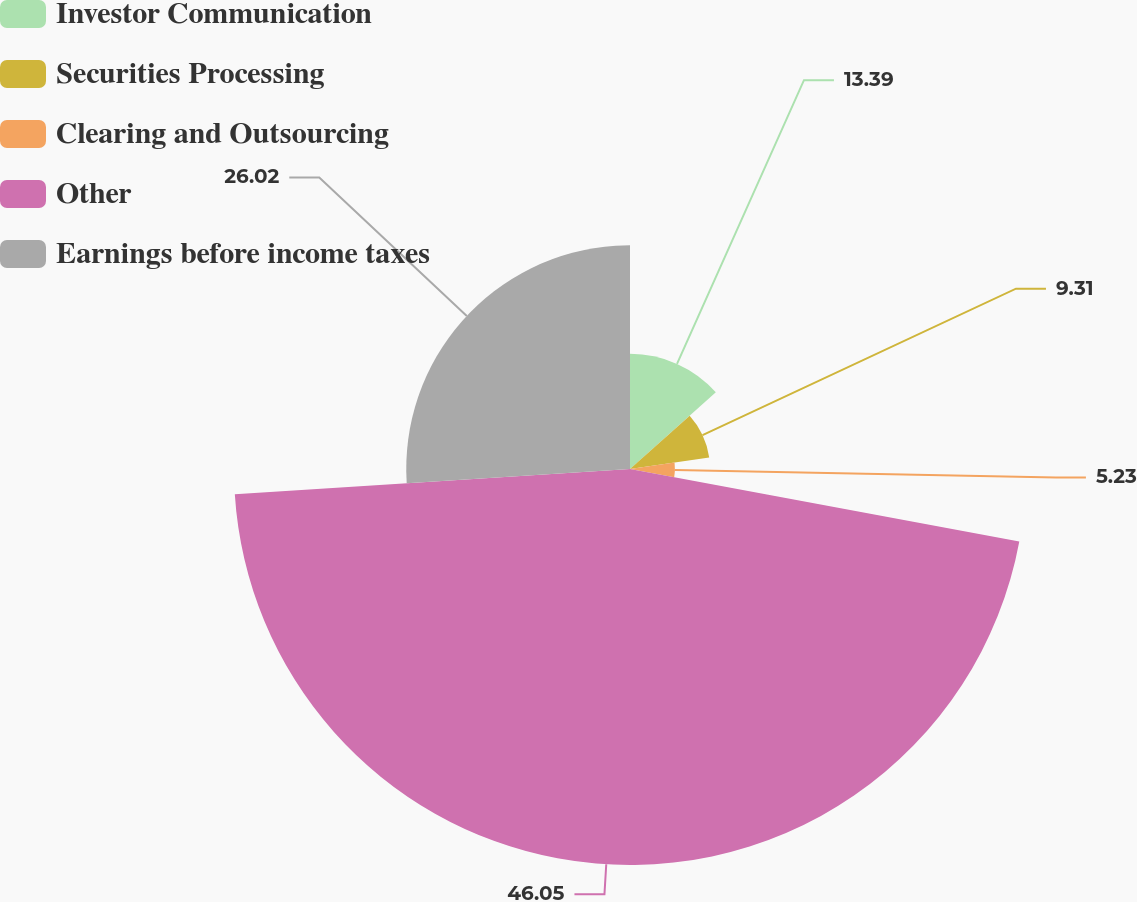Convert chart to OTSL. <chart><loc_0><loc_0><loc_500><loc_500><pie_chart><fcel>Investor Communication<fcel>Securities Processing<fcel>Clearing and Outsourcing<fcel>Other<fcel>Earnings before income taxes<nl><fcel>13.39%<fcel>9.31%<fcel>5.23%<fcel>46.05%<fcel>26.02%<nl></chart> 